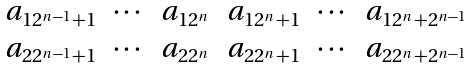<formula> <loc_0><loc_0><loc_500><loc_500>\begin{matrix} a _ { 1 2 ^ { n - 1 } + 1 } & \cdots & a _ { 1 2 ^ { n } } & a _ { 1 2 ^ { n } + 1 } & \cdots & a _ { 1 2 ^ { n } + 2 ^ { n - 1 } } \\ a _ { 2 2 ^ { n - 1 } + 1 } & \cdots & a _ { 2 2 ^ { n } } & a _ { 2 2 ^ { n } + 1 } & \cdots & a _ { 2 2 ^ { n } + 2 ^ { n - 1 } } \end{matrix}</formula> 